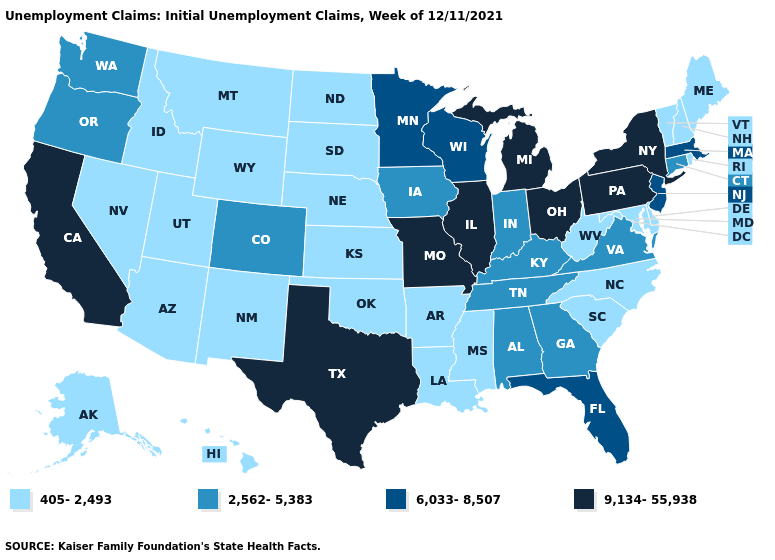Name the states that have a value in the range 2,562-5,383?
Quick response, please. Alabama, Colorado, Connecticut, Georgia, Indiana, Iowa, Kentucky, Oregon, Tennessee, Virginia, Washington. What is the value of Delaware?
Short answer required. 405-2,493. Which states have the lowest value in the Northeast?
Short answer required. Maine, New Hampshire, Rhode Island, Vermont. What is the value of Pennsylvania?
Answer briefly. 9,134-55,938. Name the states that have a value in the range 405-2,493?
Short answer required. Alaska, Arizona, Arkansas, Delaware, Hawaii, Idaho, Kansas, Louisiana, Maine, Maryland, Mississippi, Montana, Nebraska, Nevada, New Hampshire, New Mexico, North Carolina, North Dakota, Oklahoma, Rhode Island, South Carolina, South Dakota, Utah, Vermont, West Virginia, Wyoming. Is the legend a continuous bar?
Short answer required. No. What is the value of Iowa?
Answer briefly. 2,562-5,383. Does Nebraska have the highest value in the MidWest?
Be succinct. No. What is the lowest value in the USA?
Be succinct. 405-2,493. Is the legend a continuous bar?
Concise answer only. No. Which states have the lowest value in the USA?
Answer briefly. Alaska, Arizona, Arkansas, Delaware, Hawaii, Idaho, Kansas, Louisiana, Maine, Maryland, Mississippi, Montana, Nebraska, Nevada, New Hampshire, New Mexico, North Carolina, North Dakota, Oklahoma, Rhode Island, South Carolina, South Dakota, Utah, Vermont, West Virginia, Wyoming. What is the highest value in states that border Nebraska?
Concise answer only. 9,134-55,938. What is the highest value in the USA?
Give a very brief answer. 9,134-55,938. Among the states that border Maryland , does Pennsylvania have the highest value?
Write a very short answer. Yes. What is the lowest value in the USA?
Be succinct. 405-2,493. 